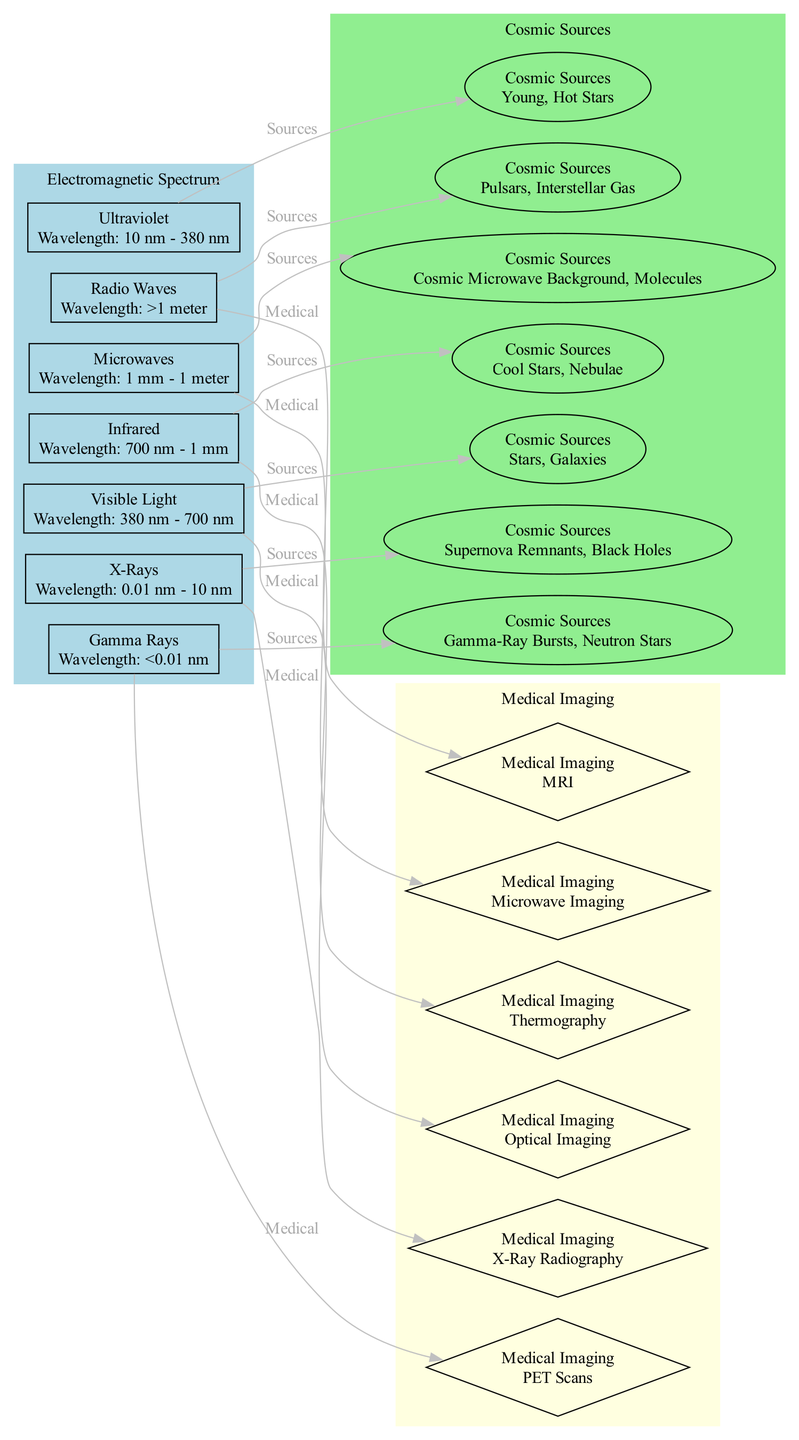What is the wavelength range of X-Rays? According to the diagram, X-Rays have a wavelength range of 0.01 nm - 10 nm, which is listed in the details of the X-Rays node.
Answer: 0.01 nm - 10 nm What cosmic source is associated with visible light? The diagram connects the "Visible Light" node to the "Stars, Galaxies" node, indicating that this is the cosmic source related to visible light.
Answer: Stars, Galaxies How many medical imaging technologies are depicted in the diagram? The diagram lists six nodes under the "Medical Imaging" section, each representing a different technology, providing a straightforward count.
Answer: 6 Which type of waves are used in MRI? The "Medical Imaging" section directly links "Radio Waves" to "MRI," indicating that radio waves are utilized in this medical technology.
Answer: Radio Waves What cosmic source generates gamma rays? According to the diagram, the cosmic source responsible for gamma rays is categorized under the "Gamma Rays" node and is listed as "Gamma-Ray Bursts, Neutron Stars."
Answer: Gamma-Ray Bursts, Neutron Stars Which medical imaging technique is associated with microwaves? The edge from "Microwaves" to "Microwave Imaging" indicates that microwave imaging is the medical imaging technique associated specifically with microwaves.
Answer: Microwave Imaging How many wavelengths are depicted in the diagram? The diagram lists a total of seven different wavelengths represented by nodes in the "Electromagnetic Spectrum" section, thus providing a direct count.
Answer: 7 What is the source for infrared wavelengths? The node for "Infrared" is connected to "Cool Stars, Nebulae," which clearly shows that these are the cosmic sources associated with infrared wavelengths in the diagram.
Answer: Cool Stars, Nebulae What is the primary application of gamma rays in medicine? The diagram connects "Gamma Rays" with "PET Scans," indicating that PET scans are the primary medical imaging application associated with gamma rays.
Answer: PET Scans 